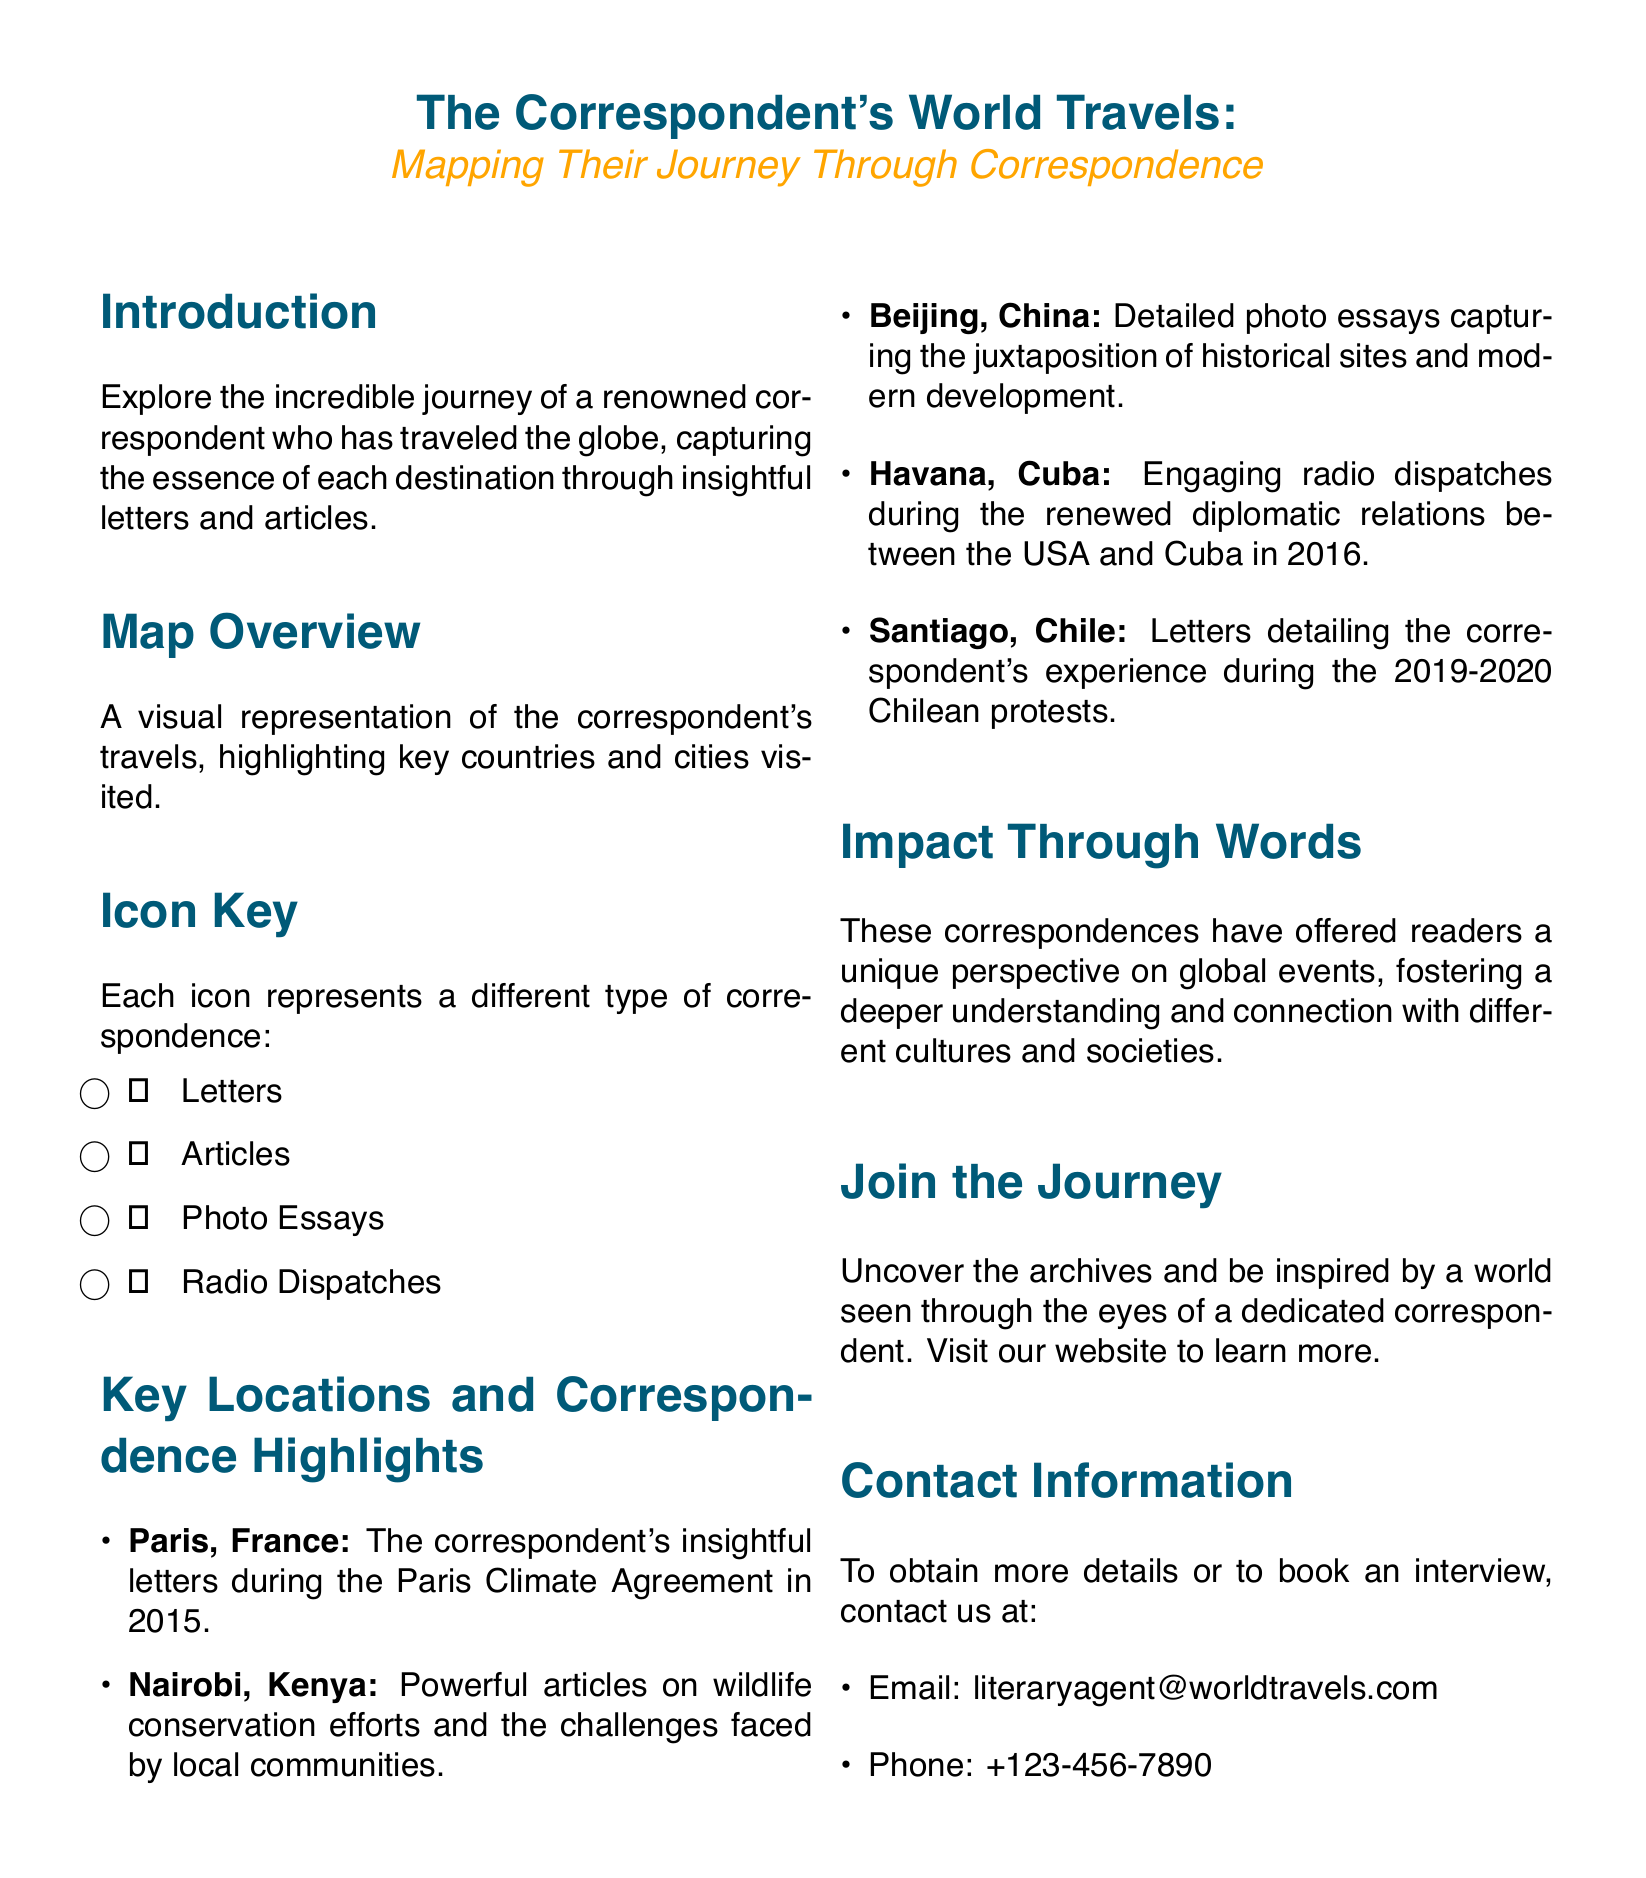What is the main subject of the flyer? The flyer covers the travels of a correspondent and their experiences depicted through correspondence.
Answer: The Correspondent's World Travels What is the color used for the main title? The title's color is specified in the document as the main color.
Answer: RGB(0,90,120) How many types of correspondence are illustrated? The document mentions different types of correspondence represented by icons.
Answer: Four Which city relates to the 2016 diplomatic relations between the USA and Cuba? The corresponding letter refers to a specific city where these events took place.
Answer: Havana What significant event occurred in Paris in 2015 according to the flyer? The document specifies the letters related to a notable global event in Paris.
Answer: Paris Climate Agreement What type of correspondence is represented by the icon of a letter? Each type of correspondence is represented by different icons, and one is for letters.
Answer: Letters Which country is highlighted for its wildlife conservation efforts? The flyer lists important locations and their related topics.
Answer: Kenya What website should people visit to uncover more archives? The flyer prompts readers to visit a specific online source for further information.
Answer: Visit our website What contact method is provided for booking an interview? The document lists contact methods for those seeking more information or to book interviews.
Answer: Email 